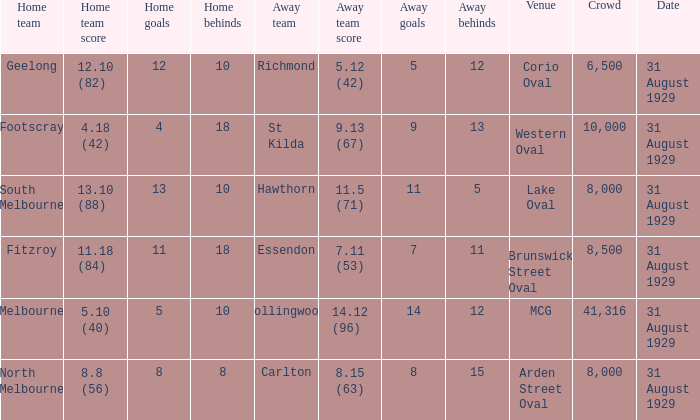What is the score of the away team when the crowd was larger than 8,000? 9.13 (67), 7.11 (53), 14.12 (96). 